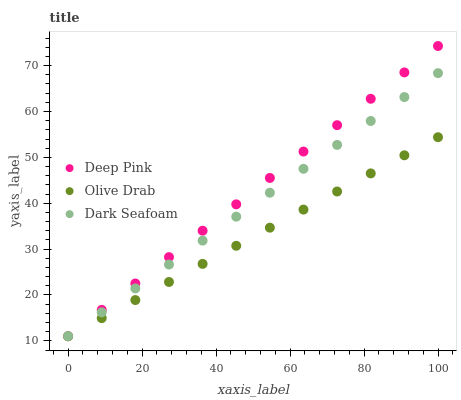Does Olive Drab have the minimum area under the curve?
Answer yes or no. Yes. Does Deep Pink have the maximum area under the curve?
Answer yes or no. Yes. Does Deep Pink have the minimum area under the curve?
Answer yes or no. No. Does Olive Drab have the maximum area under the curve?
Answer yes or no. No. Is Olive Drab the smoothest?
Answer yes or no. Yes. Is Deep Pink the roughest?
Answer yes or no. Yes. Is Deep Pink the smoothest?
Answer yes or no. No. Is Olive Drab the roughest?
Answer yes or no. No. Does Dark Seafoam have the lowest value?
Answer yes or no. Yes. Does Deep Pink have the highest value?
Answer yes or no. Yes. Does Olive Drab have the highest value?
Answer yes or no. No. Does Dark Seafoam intersect Deep Pink?
Answer yes or no. Yes. Is Dark Seafoam less than Deep Pink?
Answer yes or no. No. Is Dark Seafoam greater than Deep Pink?
Answer yes or no. No. 